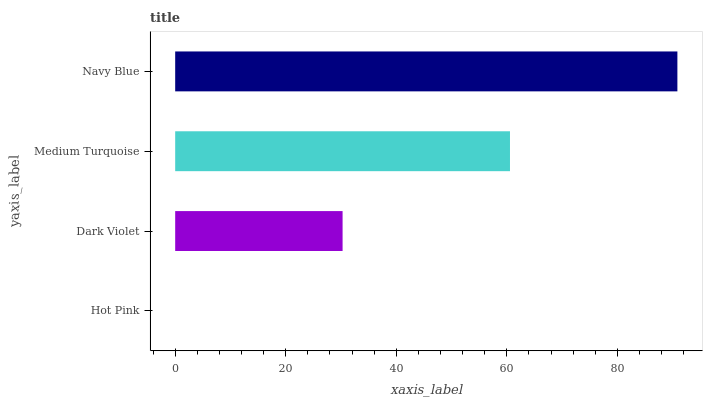Is Hot Pink the minimum?
Answer yes or no. Yes. Is Navy Blue the maximum?
Answer yes or no. Yes. Is Dark Violet the minimum?
Answer yes or no. No. Is Dark Violet the maximum?
Answer yes or no. No. Is Dark Violet greater than Hot Pink?
Answer yes or no. Yes. Is Hot Pink less than Dark Violet?
Answer yes or no. Yes. Is Hot Pink greater than Dark Violet?
Answer yes or no. No. Is Dark Violet less than Hot Pink?
Answer yes or no. No. Is Medium Turquoise the high median?
Answer yes or no. Yes. Is Dark Violet the low median?
Answer yes or no. Yes. Is Navy Blue the high median?
Answer yes or no. No. Is Medium Turquoise the low median?
Answer yes or no. No. 